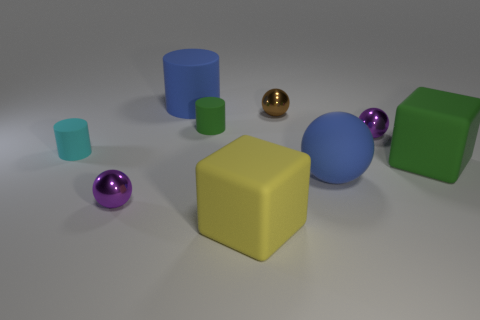Subtract all large matte cylinders. How many cylinders are left? 2 Subtract all gray cylinders. How many purple balls are left? 2 Subtract all brown spheres. How many spheres are left? 3 Subtract 2 spheres. How many spheres are left? 2 Add 1 spheres. How many objects exist? 10 Subtract all balls. How many objects are left? 5 Subtract all big brown balls. Subtract all big blue matte things. How many objects are left? 7 Add 3 big green things. How many big green things are left? 4 Add 1 gray metal objects. How many gray metal objects exist? 1 Subtract 1 blue spheres. How many objects are left? 8 